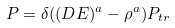<formula> <loc_0><loc_0><loc_500><loc_500>P = \delta ( ( D E ) ^ { a } - \rho ^ { a } ) P _ { t r }</formula> 